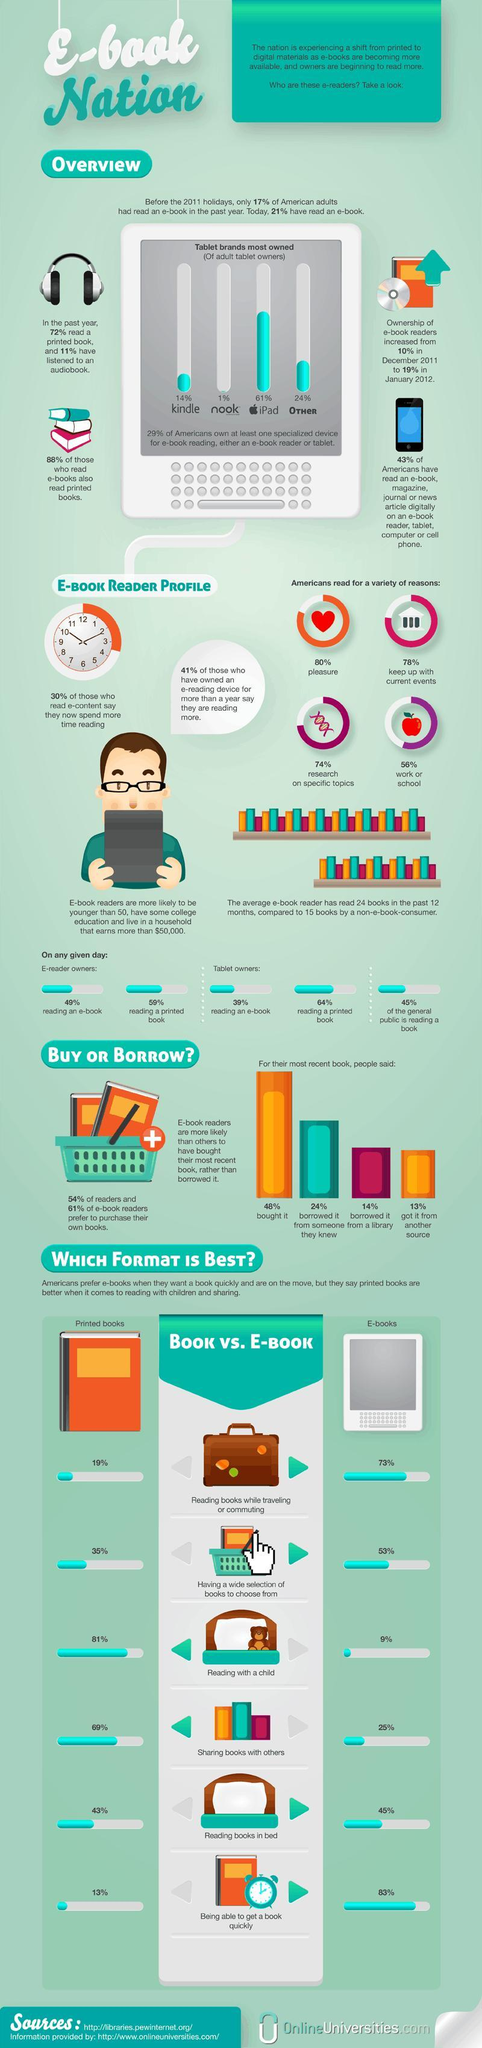What percentage of Americans read not for research purposes?
Answer the question with a short phrase. 26% What percentage of Americans read not for work? 44% Which format is best for reading books in bed? E-books Which format is best for reading books while traveling or commuting? E-books Which format is best for reading with a child? Printed books What percentage of Americans read not for pleasure? 20% What percentage of Americans own both kindle and nook together for e-book reading? 15% 